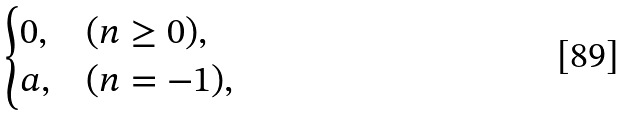Convert formula to latex. <formula><loc_0><loc_0><loc_500><loc_500>\begin{cases} 0 , & ( n \geq 0 ) , \\ a , & ( n = - 1 ) , \end{cases}</formula> 